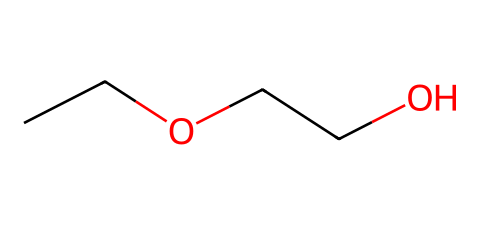What is the common name of this compound? The SMILES representation indicates that the chemical is 2-ethoxyethanol, which is a common name derived from its IUPAC nomenclature. The structure reveals an ether functional group attached to an ethanol molecule.
Answer: 2-ethoxyethanol How many carbon atoms are present in this molecule? By examining the SMILES representation, "CCOCCO," we can identify that there are 4 carbon atoms total, counting the 'C' letters in the sequence.
Answer: 4 What type of functional group is present in this compound? The presence of "O" between two carbon chains in the SMILES indicates that this compound features an ether functional group. Ethers are characterized by an oxygen atom connected to two alkyl or aryl groups.
Answer: ether Which part of the structure contributes to its cleaning properties? The hydroxyl group present in 2-ethoxyethanol (due to the 'O' connected to carbon) contributes to its ability to dissolve polar compounds, making it effective as a cleaning agent.
Answer: hydroxyl group What is the boiling point range of 2-ethoxyethanol? The physical properties of 2-ethoxyethanol include a boiling point range of approximately 135-140 degrees Celsius, typical for solvents in its class.
Answer: 135-140 degrees Celsius Is this compound polar or nonpolar? The presence of the hydroxyl group makes 2-ethoxyethanol a polar compound, as its structure facilitates dipole-dipole interactions due to the electronegativity difference between oxygen and carbon/hydrogen.
Answer: polar 